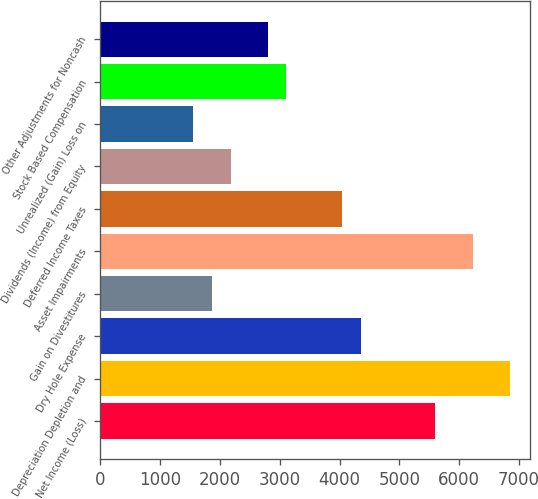Convert chart to OTSL. <chart><loc_0><loc_0><loc_500><loc_500><bar_chart><fcel>Net Income (Loss)<fcel>Depreciation Depletion and<fcel>Dry Hole Expense<fcel>Gain on Divestitures<fcel>Asset Impairments<fcel>Deferred Income Taxes<fcel>Dividends (Income) from Equity<fcel>Unrealized (Gain) Loss on<fcel>Stock Based Compensation<fcel>Other Adjustments for Noncash<nl><fcel>5601.8<fcel>6846.2<fcel>4357.4<fcel>1868.6<fcel>6224<fcel>4046.3<fcel>2179.7<fcel>1557.5<fcel>3113<fcel>2801.9<nl></chart> 